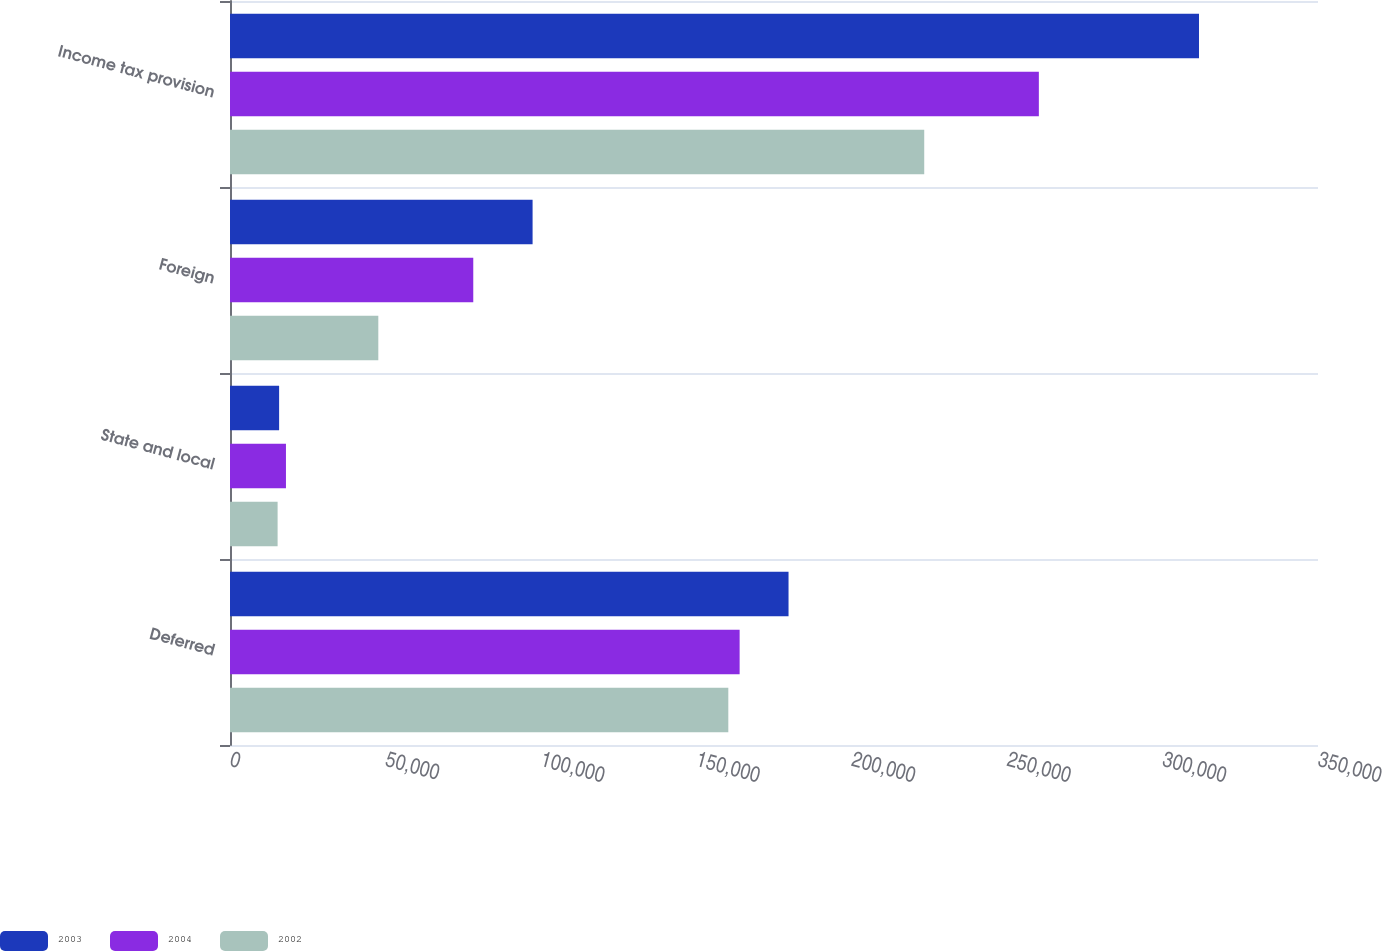Convert chart. <chart><loc_0><loc_0><loc_500><loc_500><stacked_bar_chart><ecel><fcel>Deferred<fcel>State and local<fcel>Foreign<fcel>Income tax provision<nl><fcel>2003<fcel>179677<fcel>15800<fcel>97340<fcel>311717<nl><fcel>2004<fcel>163944<fcel>18000<fcel>78257<fcel>260201<nl><fcel>2002<fcel>160302<fcel>15315<fcel>47710<fcel>223327<nl></chart> 